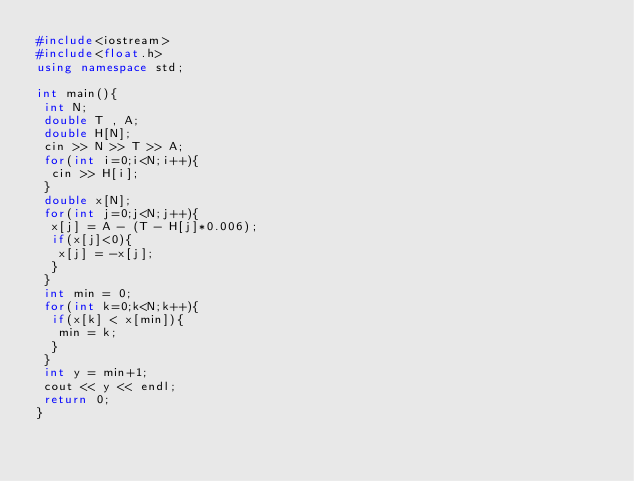Convert code to text. <code><loc_0><loc_0><loc_500><loc_500><_C++_>#include<iostream>
#include<float.h>
using namespace std;

int main(){
 int N;
 double T , A;
 double H[N];
 cin >> N >> T >> A;
 for(int i=0;i<N;i++){
  cin >> H[i];
 }
 double x[N];
 for(int j=0;j<N;j++){
  x[j] = A - (T - H[j]*0.006);
  if(x[j]<0){
   x[j] = -x[j];
  }
 }
 int min = 0;
 for(int k=0;k<N;k++){
  if(x[k] < x[min]){
   min = k;
  }
 }
 int y = min+1;
 cout << y << endl;
 return 0;
}
  
  </code> 